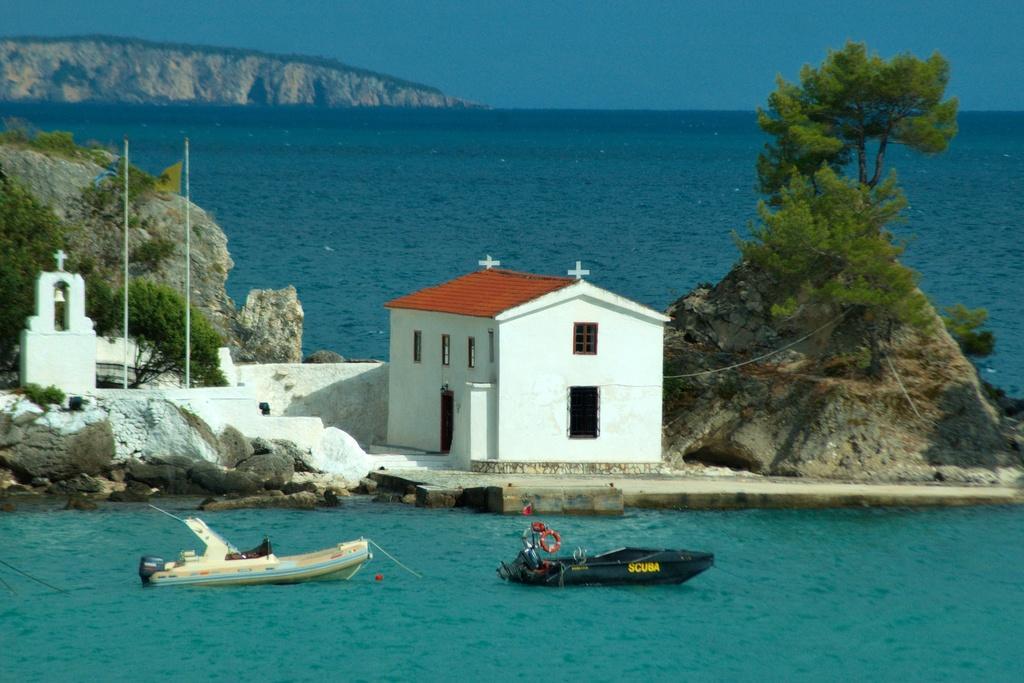Describe this image in one or two sentences. In this image, I can see a building. On the left side of the image, I can see two flags hanging to the poles. There are trees, rocks and hills. At the bottom of the image, I can see two boats on the water. In the background, there is the sky. 